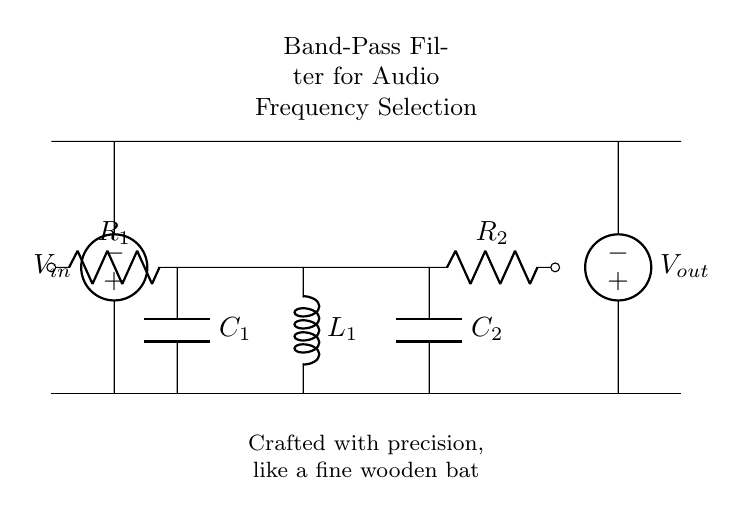What are the components used in the circuit? The circuit includes resistors, capacitors, an inductor, and voltage sources. Specifically, there are two resistors (R1 and R2), two capacitors (C1 and C2), one inductor (L1), and input/output voltage sources.
Answer: resistors, capacitors, inductor, voltage sources What is the purpose of this circuit? This circuit is a band-pass filter designed to allow a specific range of audio frequencies to pass while attenuating frequencies outside this range.
Answer: band-pass filter How many voltage sources are present in the circuit? There are two voltage sources in the circuit: one for input and one for output, indicated as V_in and V_out.
Answer: two Which element is connected to ground in the circuit? The lower terminal of the resistors (R1 and R2), the capacitors (C1 and C2), and the inductor (L1) are connected to ground, forming the reference point for all voltages.
Answer: resistors, capacitors, inductor What is the configuration of the filter regarding the components? The filter is configured in a manner that places both capacitors in series with the inductor, while the resistors are arranged to control the circuit's gain and frequency response.
Answer: series and parallel combination How does the filter affect frequencies outside the passband? Frequencies outside the designated range will be attenuated, meaning they will be weakened significantly as they pass through the circuit, preventing them from reaching the output voltage source.
Answer: attenuates What is the output voltage source labeled as? The output voltage source is labeled as V_out, indicating the point where the filtered audio signal can be measured.
Answer: V_out 